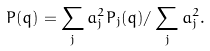Convert formula to latex. <formula><loc_0><loc_0><loc_500><loc_500>P ( { q } ) = \sum _ { j } a ^ { 2 } _ { j } P _ { j } ( { q } ) / \sum _ { j } a _ { j } ^ { 2 } .</formula> 